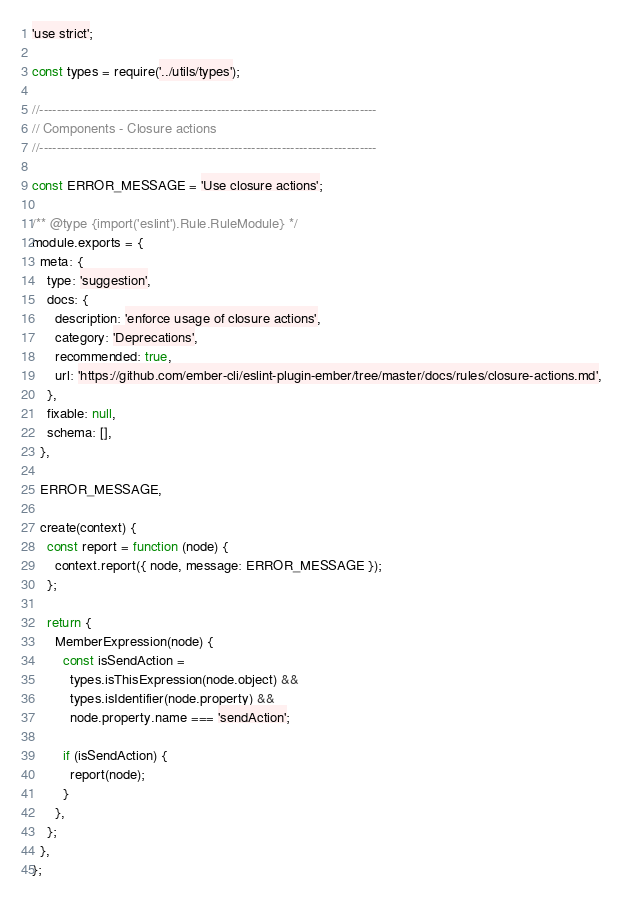Convert code to text. <code><loc_0><loc_0><loc_500><loc_500><_JavaScript_>'use strict';

const types = require('../utils/types');

//------------------------------------------------------------------------------
// Components - Closure actions
//------------------------------------------------------------------------------

const ERROR_MESSAGE = 'Use closure actions';

/** @type {import('eslint').Rule.RuleModule} */
module.exports = {
  meta: {
    type: 'suggestion',
    docs: {
      description: 'enforce usage of closure actions',
      category: 'Deprecations',
      recommended: true,
      url: 'https://github.com/ember-cli/eslint-plugin-ember/tree/master/docs/rules/closure-actions.md',
    },
    fixable: null,
    schema: [],
  },

  ERROR_MESSAGE,

  create(context) {
    const report = function (node) {
      context.report({ node, message: ERROR_MESSAGE });
    };

    return {
      MemberExpression(node) {
        const isSendAction =
          types.isThisExpression(node.object) &&
          types.isIdentifier(node.property) &&
          node.property.name === 'sendAction';

        if (isSendAction) {
          report(node);
        }
      },
    };
  },
};
</code> 